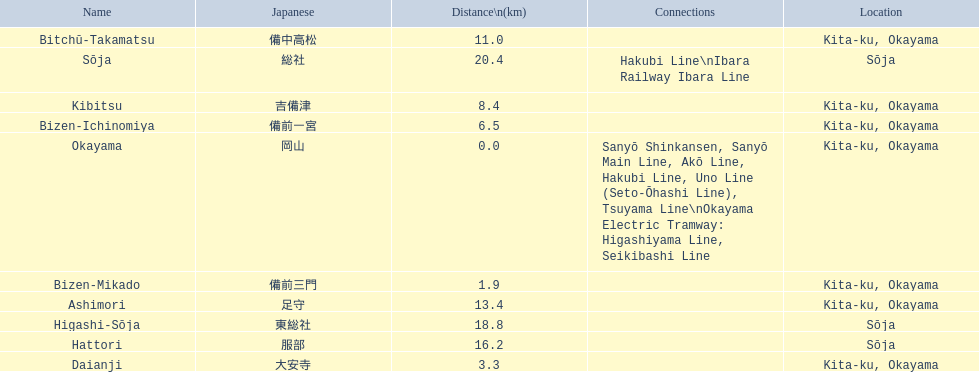What are all of the train names? Okayama, Bizen-Mikado, Daianji, Bizen-Ichinomiya, Kibitsu, Bitchū-Takamatsu, Ashimori, Hattori, Higashi-Sōja, Sōja. What is the distance for each? 0.0, 1.9, 3.3, 6.5, 8.4, 11.0, 13.4, 16.2, 18.8, 20.4. And which train's distance is between 1 and 2 km? Bizen-Mikado. 